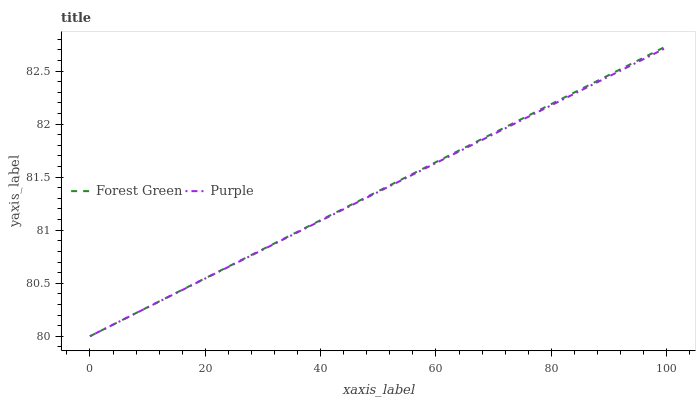Does Purple have the minimum area under the curve?
Answer yes or no. Yes. Does Forest Green have the maximum area under the curve?
Answer yes or no. Yes. Does Forest Green have the minimum area under the curve?
Answer yes or no. No. Is Purple the smoothest?
Answer yes or no. Yes. Is Forest Green the roughest?
Answer yes or no. Yes. Is Forest Green the smoothest?
Answer yes or no. No. Does Purple have the lowest value?
Answer yes or no. Yes. Does Forest Green have the highest value?
Answer yes or no. Yes. Does Purple intersect Forest Green?
Answer yes or no. Yes. Is Purple less than Forest Green?
Answer yes or no. No. Is Purple greater than Forest Green?
Answer yes or no. No. 